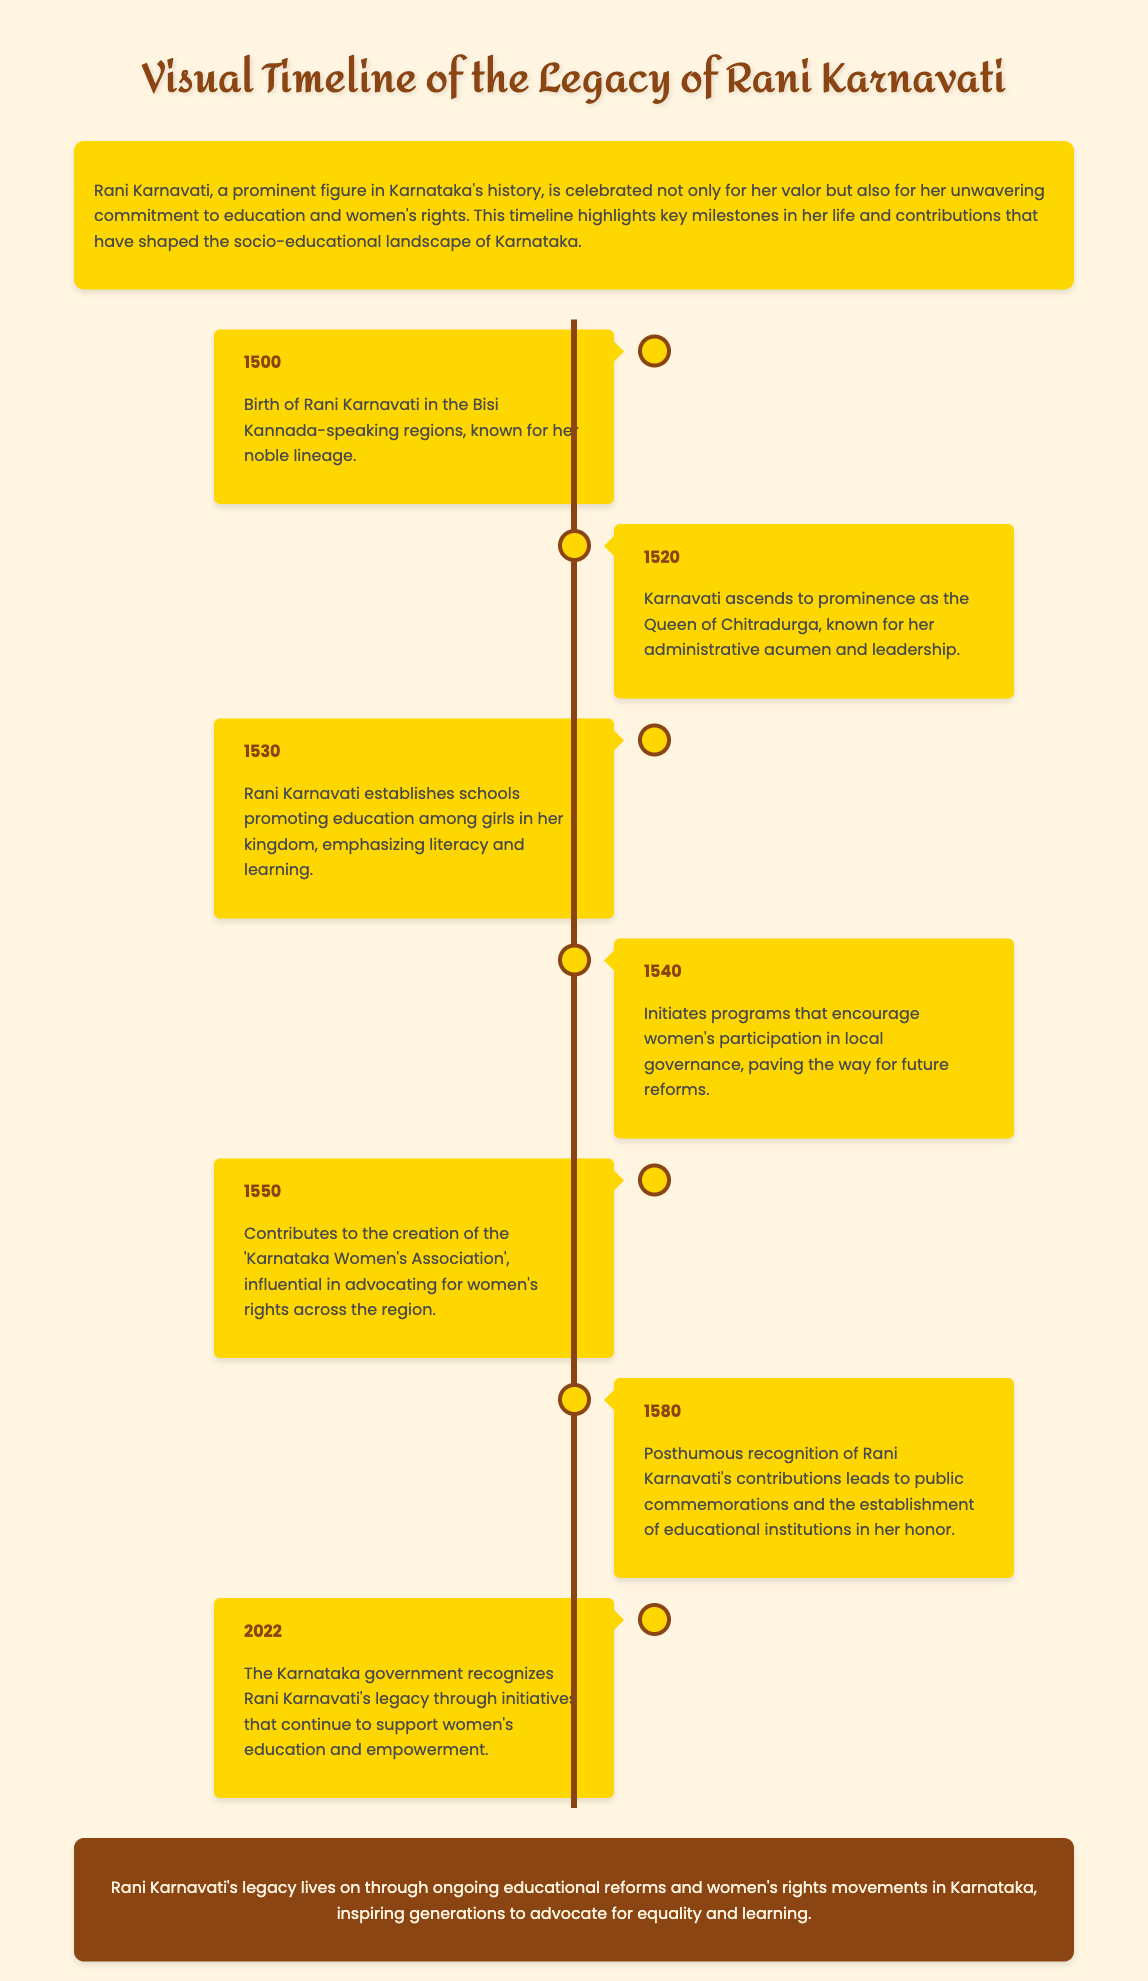What year was Rani Karnavati born? The document states that Rani Karnavati was born in the year 1500.
Answer: 1500 What initiative did she start in 1530? The timeline mentions that in 1530, Rani Karnavati established schools promoting education among girls.
Answer: Schools for girls Which association did she contribute to in 1550? According to the document, Rani Karnavati contributed to the creation of the 'Karnataka Women's Association'.
Answer: Karnataka Women's Association In what year did the Karnataka government recognize her legacy? The document specifies that the Karnataka government recognized Rani Karnavati's legacy in 2022.
Answer: 2022 What was one of Rani Karnavati's contributions in 1540? The timeline indicates that in 1540, she initiated programs encouraging women's participation in local governance.
Answer: Women's participation in governance How many years are between her birth and her posthumous recognition in 1580? The document states she was born in 1500 and recognized in 1580, making the difference 80 years.
Answer: 80 years What military skill is Rani Karnavati known for? The introduction mentions she is celebrated for her valor, indicating her military skills.
Answer: Valor What aspect of society did Rani Karnavati significantly impact? The timeline highlights her contributions to education and women's rights as significant impacts on society.
Answer: Education and women's rights 